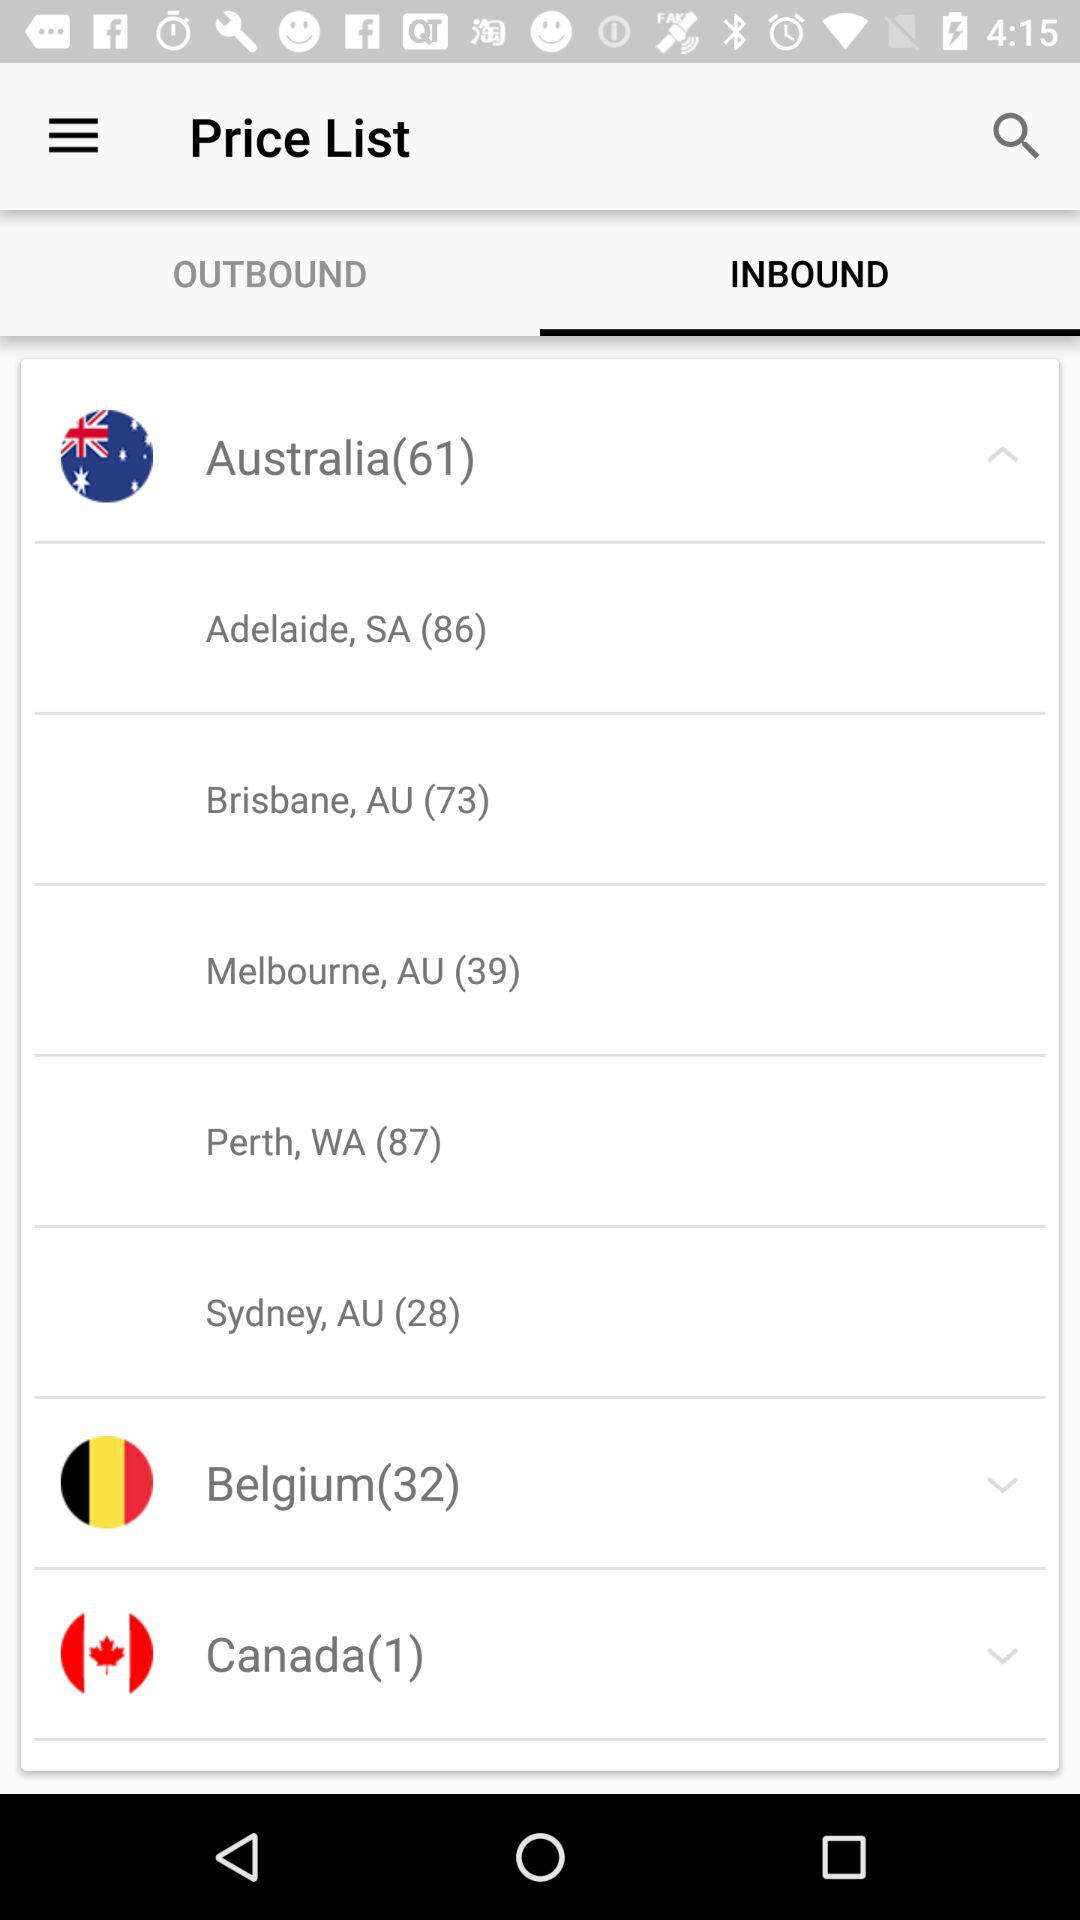What is the selected tab? The selected tab is "INBOUND". 